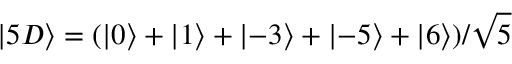<formula> <loc_0><loc_0><loc_500><loc_500>\left | 5 D \right \rangle = ( \left | 0 \right \rangle + \left | 1 \right \rangle + \left | - 3 \right \rangle + \left | - 5 \right \rangle + \left | 6 \right \rangle ) / \sqrt { 5 }</formula> 